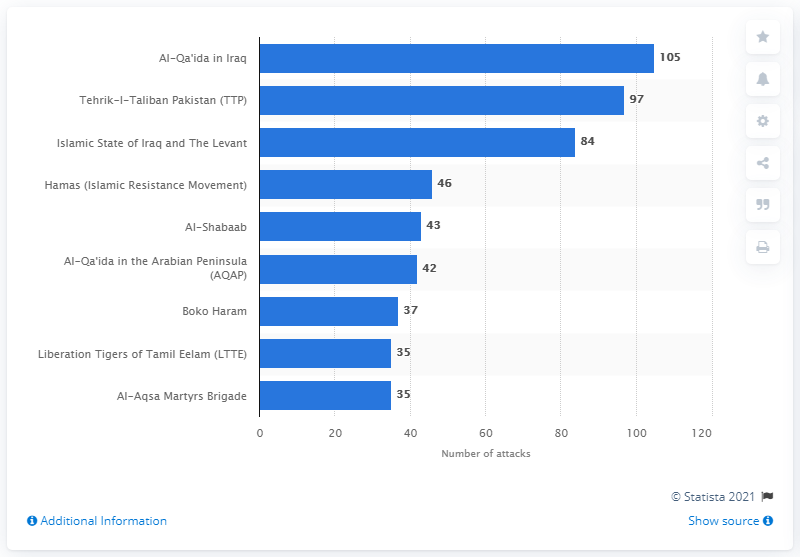Mention a couple of crucial points in this snapshot. Between 2000 and 2013, Boko Haram claimed a total of 37 suicide attacks. 